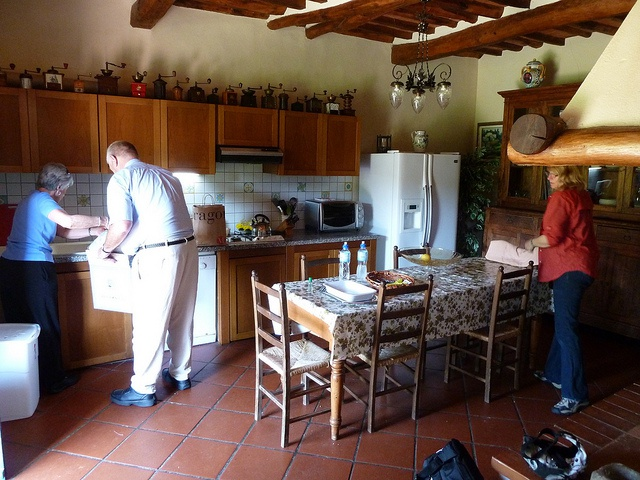Describe the objects in this image and their specific colors. I can see people in maroon, white, gray, and darkgray tones, people in maroon, black, brown, and navy tones, people in maroon, black, lightblue, lavender, and gray tones, refrigerator in maroon, darkgray, lightblue, and gray tones, and chair in maroon, lightgray, gray, and black tones in this image. 